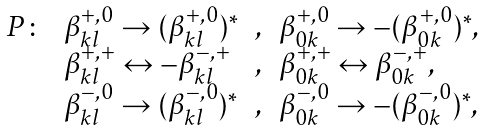<formula> <loc_0><loc_0><loc_500><loc_500>\begin{array} { l l c l } P \colon & \beta ^ { + , 0 } _ { k l } \rightarrow ( \beta ^ { + , 0 } _ { k l } ) ^ { * } & , & \beta ^ { + , 0 } _ { 0 k } \rightarrow - ( \beta ^ { + , 0 } _ { 0 k } ) ^ { * } , \\ & \beta ^ { + , + } _ { k l } \leftrightarrow - \beta ^ { - , + } _ { k l } & , & \beta ^ { + , + } _ { 0 k } \leftrightarrow \beta ^ { - , + } _ { 0 k } , \\ & \beta ^ { - , 0 } _ { k l } \rightarrow ( \beta ^ { - , 0 } _ { k l } ) ^ { * } & , & \beta ^ { - , 0 } _ { 0 k } \rightarrow - ( \beta ^ { - , 0 } _ { 0 k } ) ^ { * } , \end{array}</formula> 